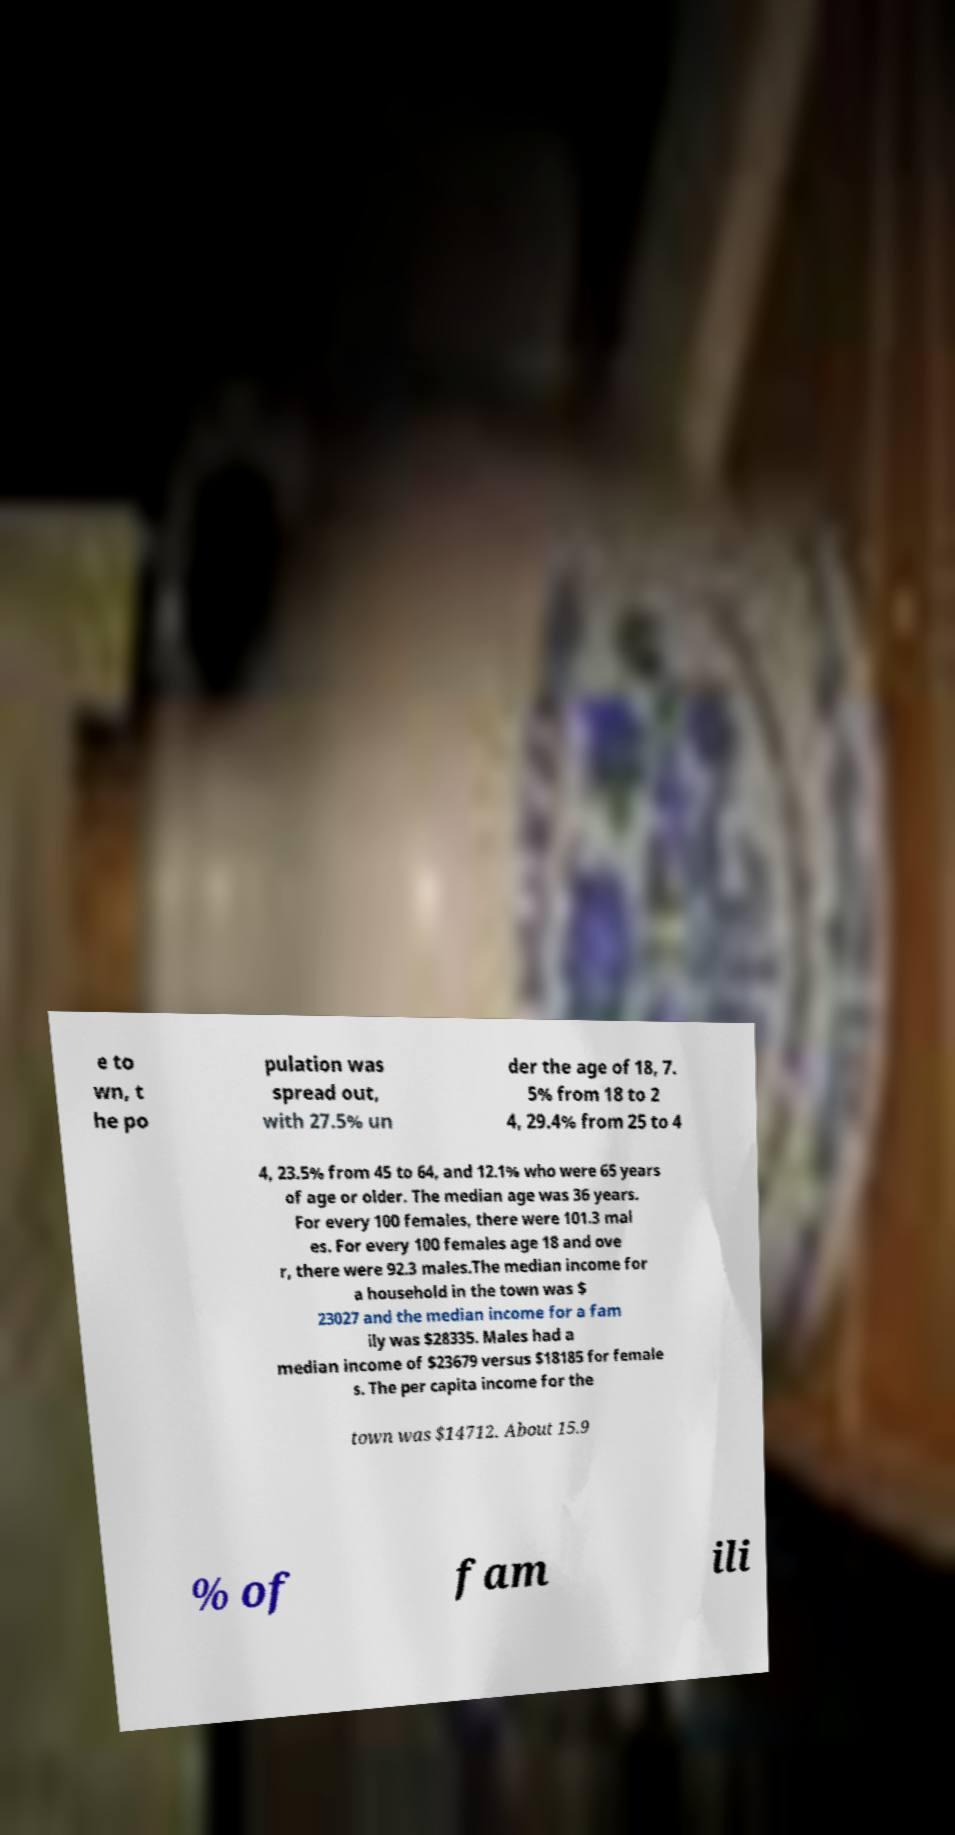Could you extract and type out the text from this image? e to wn, t he po pulation was spread out, with 27.5% un der the age of 18, 7. 5% from 18 to 2 4, 29.4% from 25 to 4 4, 23.5% from 45 to 64, and 12.1% who were 65 years of age or older. The median age was 36 years. For every 100 females, there were 101.3 mal es. For every 100 females age 18 and ove r, there were 92.3 males.The median income for a household in the town was $ 23027 and the median income for a fam ily was $28335. Males had a median income of $23679 versus $18185 for female s. The per capita income for the town was $14712. About 15.9 % of fam ili 